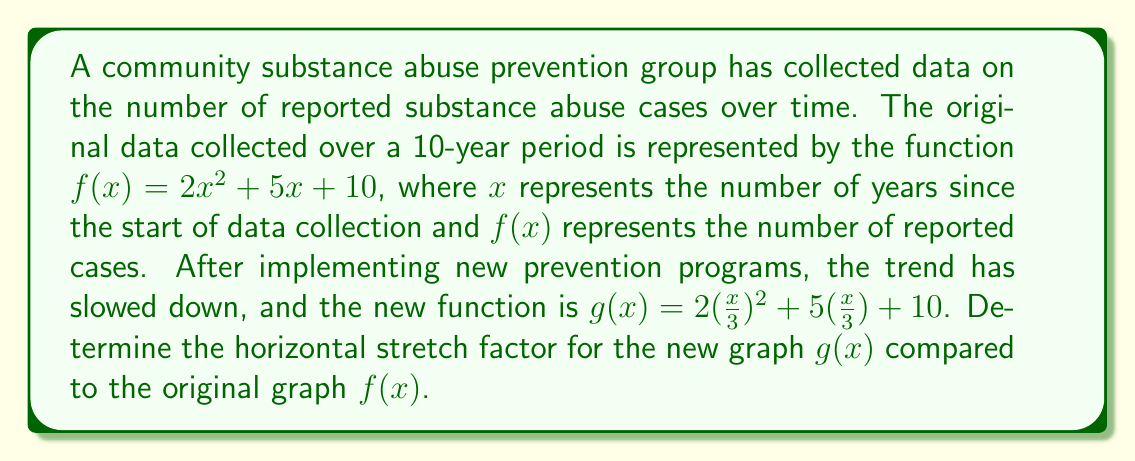Show me your answer to this math problem. To determine the horizontal stretch factor, we need to compare the original function $f(x)$ with the new function $g(x)$.

1. Original function: $f(x) = 2x^2 + 5x + 10$
2. New function: $g(x) = 2(\frac{x}{3})^2 + 5(\frac{x}{3}) + 10$

The general form of a horizontal stretch is:
$g(x) = f(\frac{x}{k})$, where $k$ is the stretch factor.

In our case, we can see that every $x$ in the original function has been replaced by $\frac{x}{3}$ in the new function:

$2x^2$ became $2(\frac{x}{3})^2$
$5x$ became $5(\frac{x}{3})$

This means that $\frac{x}{k} = \frac{x}{3}$, so $k = 3$.

A stretch factor greater than 1 indicates that the graph has been stretched horizontally. In this case, the graph of $g(x)$ is stretched horizontally by a factor of 3 compared to $f(x)$.

This stretching effect means that it now takes 3 times as long for the number of reported substance abuse cases to reach the same levels as in the original data, indicating the effectiveness of the new prevention programs.
Answer: The horizontal stretch factor is 3. 